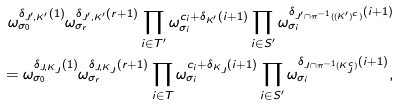Convert formula to latex. <formula><loc_0><loc_0><loc_500><loc_500>\omega _ { \sigma _ { 0 } } ^ { \delta _ { J ^ { \prime } , K ^ { \prime } } ( 1 ) } \omega _ { \sigma _ { r } } ^ { \delta _ { J ^ { \prime } , K ^ { \prime } } ( r + 1 ) } \prod _ { i \in T ^ { \prime } } \omega _ { \sigma _ { i } } ^ { c _ { i } + \delta _ { K ^ { \prime } } ( i + 1 ) } \prod _ { i \in S ^ { \prime } } \omega _ { \sigma _ { i } } ^ { \delta _ { { J ^ { \prime } \cap \pi ^ { - 1 } ( ( K ^ { \prime } ) ^ { c } ) } } ( i + 1 ) } \\ = \omega _ { \sigma _ { 0 } } ^ { \delta _ { J , K _ { J } } ( 1 ) } \omega _ { \sigma _ { r } } ^ { \delta _ { J , K _ { J } } ( r + 1 ) } \prod _ { i \in T } \omega _ { \sigma _ { i } } ^ { c _ { i } + \delta _ { K _ { J } } ( i + 1 ) } \prod _ { i \in S ^ { \prime } } \omega _ { \sigma _ { i } } ^ { \delta _ { { J \cap \pi ^ { - 1 } ( K _ { J } ^ { c } ) } } ( i + 1 ) } ,</formula> 